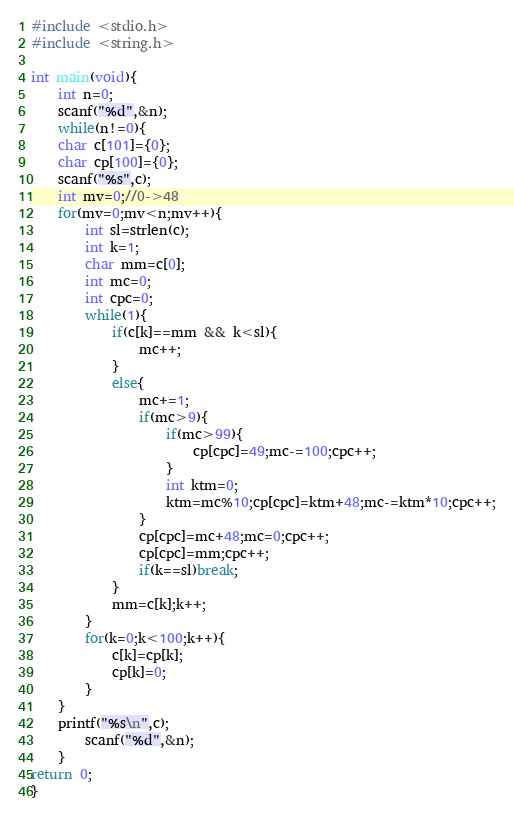Convert code to text. <code><loc_0><loc_0><loc_500><loc_500><_C_>#include <stdio.h>
#include <string.h>

int main(void){
    int n=0;
    scanf("%d",&n);
    while(n!=0){
	char c[101]={0};
	char cp[100]={0};
	scanf("%s",c);
	int mv=0;//0->48
	for(mv=0;mv<n;mv++){
		int sl=strlen(c);
		int k=1;
		char mm=c[0];
		int mc=0;
		int cpc=0;
		while(1){
			if(c[k]==mm && k<sl){
				mc++;
			}
			else{
				mc+=1;
				if(mc>9){
					if(mc>99){
						cp[cpc]=49;mc-=100;cpc++;
					}
					int ktm=0;
					ktm=mc%10;cp[cpc]=ktm+48;mc-=ktm*10;cpc++;
				}
				cp[cpc]=mc+48;mc=0;cpc++;
				cp[cpc]=mm;cpc++;
				if(k==sl)break;
			}
			mm=c[k];k++;
		}
		for(k=0;k<100;k++){
			c[k]=cp[k];
			cp[k]=0;
		}
	}
	printf("%s\n",c);
        scanf("%d",&n);
    }
return 0;
}</code> 